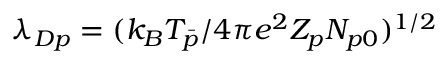Convert formula to latex. <formula><loc_0><loc_0><loc_500><loc_500>\lambda _ { D p } = ( k _ { B } T _ { \bar { p } } / 4 \pi e ^ { 2 } Z _ { p } N _ { p 0 } ) ^ { 1 / 2 }</formula> 